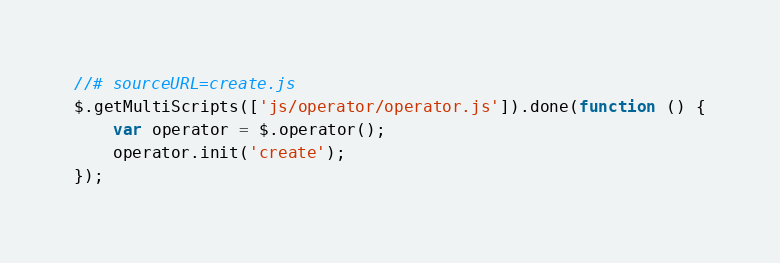<code> <loc_0><loc_0><loc_500><loc_500><_JavaScript_>//# sourceURL=create.js
$.getMultiScripts(['js/operator/operator.js']).done(function () {
    var operator = $.operator();
    operator.init('create');
});</code> 